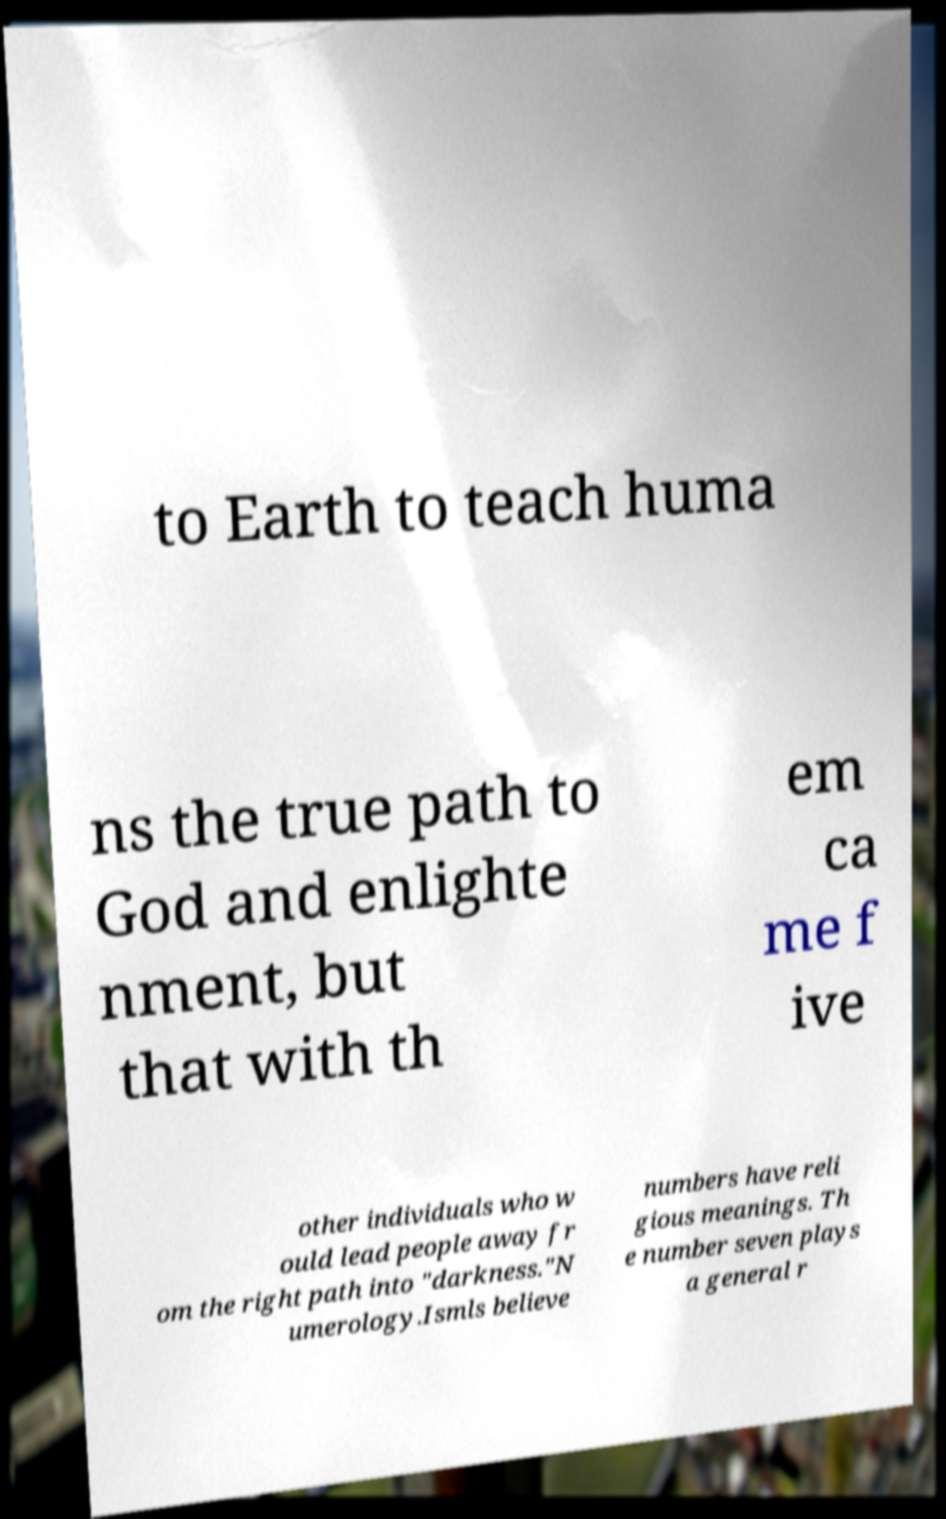There's text embedded in this image that I need extracted. Can you transcribe it verbatim? to Earth to teach huma ns the true path to God and enlighte nment, but that with th em ca me f ive other individuals who w ould lead people away fr om the right path into "darkness."N umerology.Ismls believe numbers have reli gious meanings. Th e number seven plays a general r 